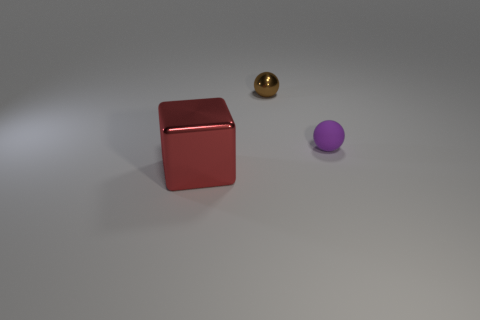Add 3 brown metal spheres. How many objects exist? 6 Subtract all balls. How many objects are left? 1 Subtract 0 cyan cylinders. How many objects are left? 3 Subtract all large yellow things. Subtract all tiny things. How many objects are left? 1 Add 1 purple rubber objects. How many purple rubber objects are left? 2 Add 1 big brown rubber blocks. How many big brown rubber blocks exist? 1 